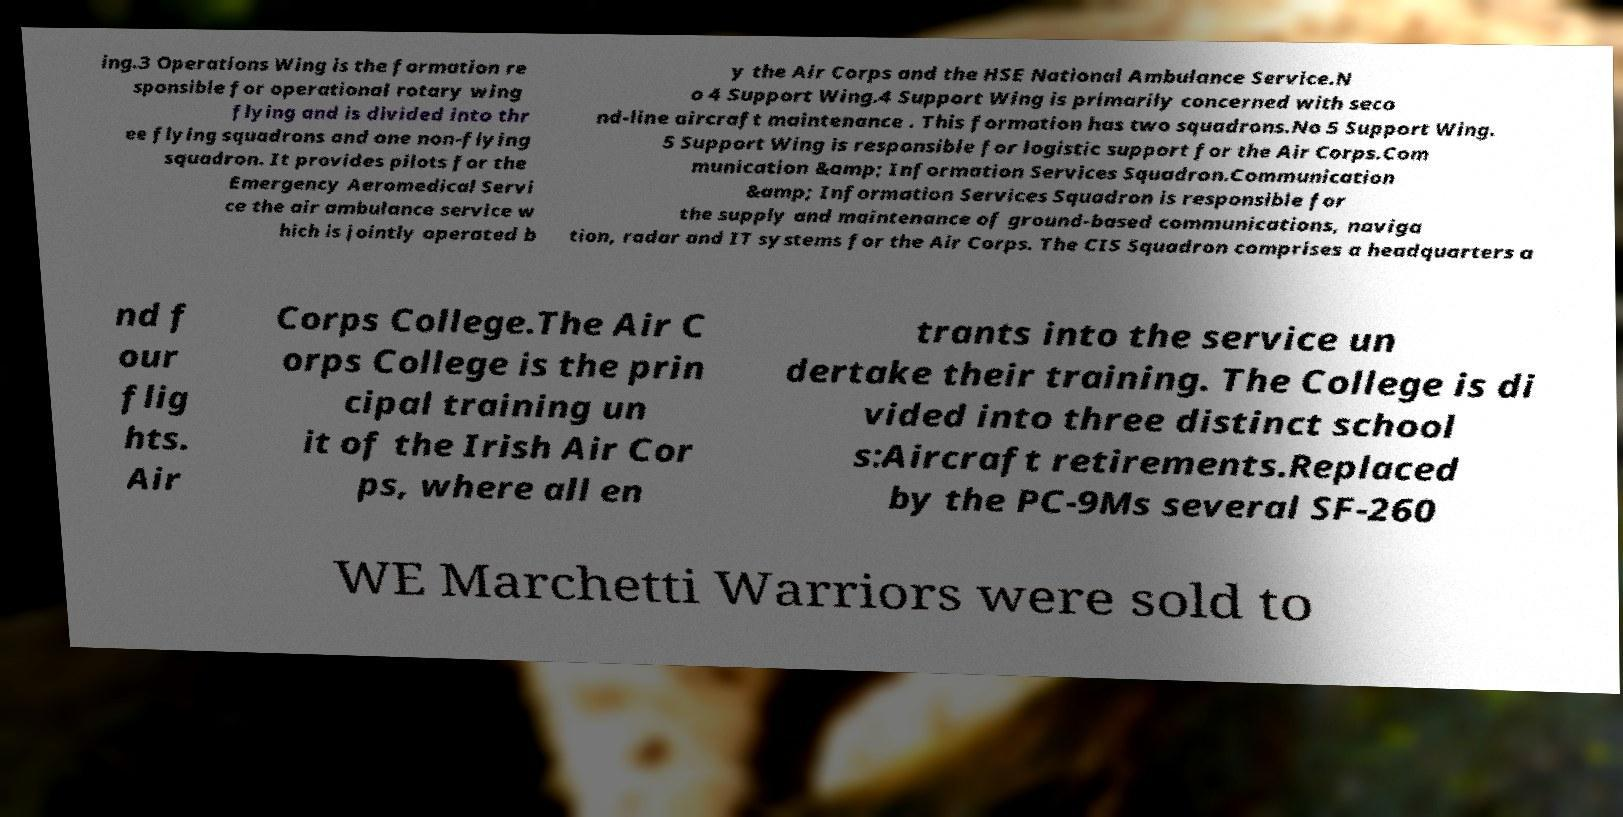Please identify and transcribe the text found in this image. ing.3 Operations Wing is the formation re sponsible for operational rotary wing flying and is divided into thr ee flying squadrons and one non-flying squadron. It provides pilots for the Emergency Aeromedical Servi ce the air ambulance service w hich is jointly operated b y the Air Corps and the HSE National Ambulance Service.N o 4 Support Wing.4 Support Wing is primarily concerned with seco nd-line aircraft maintenance . This formation has two squadrons.No 5 Support Wing. 5 Support Wing is responsible for logistic support for the Air Corps.Com munication &amp; Information Services Squadron.Communication &amp; Information Services Squadron is responsible for the supply and maintenance of ground-based communications, naviga tion, radar and IT systems for the Air Corps. The CIS Squadron comprises a headquarters a nd f our flig hts. Air Corps College.The Air C orps College is the prin cipal training un it of the Irish Air Cor ps, where all en trants into the service un dertake their training. The College is di vided into three distinct school s:Aircraft retirements.Replaced by the PC-9Ms several SF-260 WE Marchetti Warriors were sold to 